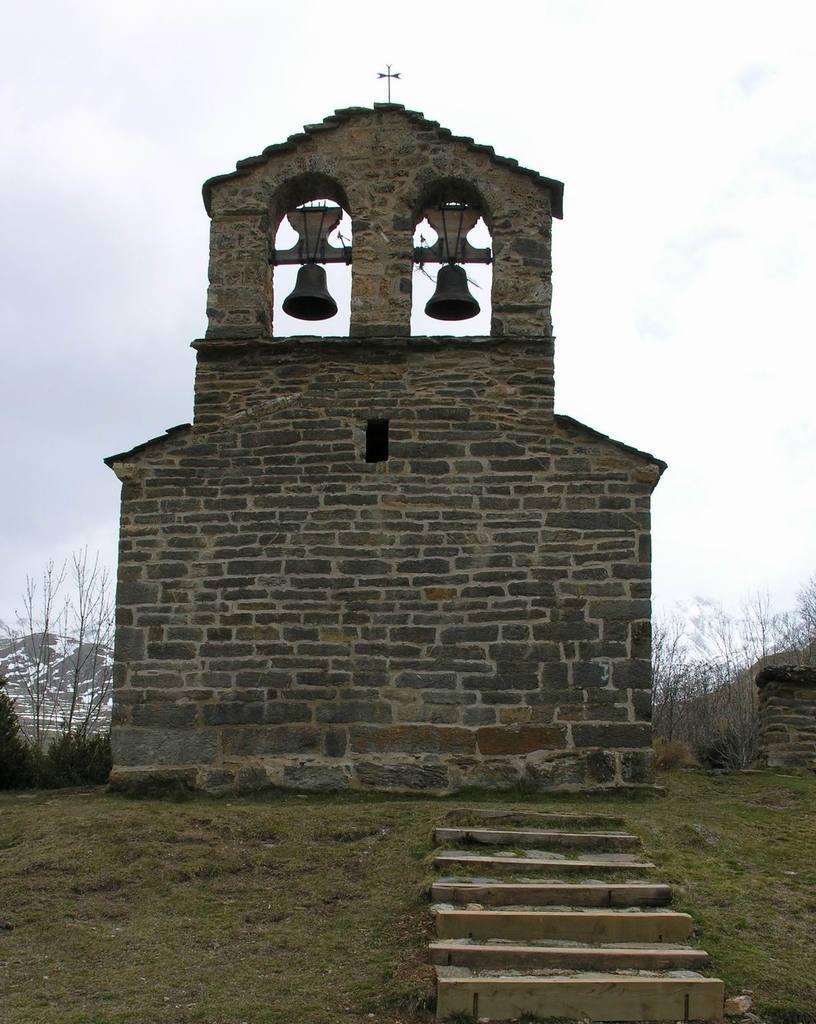Can you describe this image briefly? In this image we can see the wall, there are some trees, stairs, bells, mountains and grass on the ground, in the background, we can see the sky with clouds. 